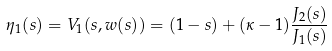<formula> <loc_0><loc_0><loc_500><loc_500>\eta _ { 1 } ( s ) = V _ { 1 } ( s , w ( s ) ) = ( 1 - s ) + ( \kappa - 1 ) \frac { J _ { 2 } ( s ) } { J _ { 1 } ( s ) }</formula> 